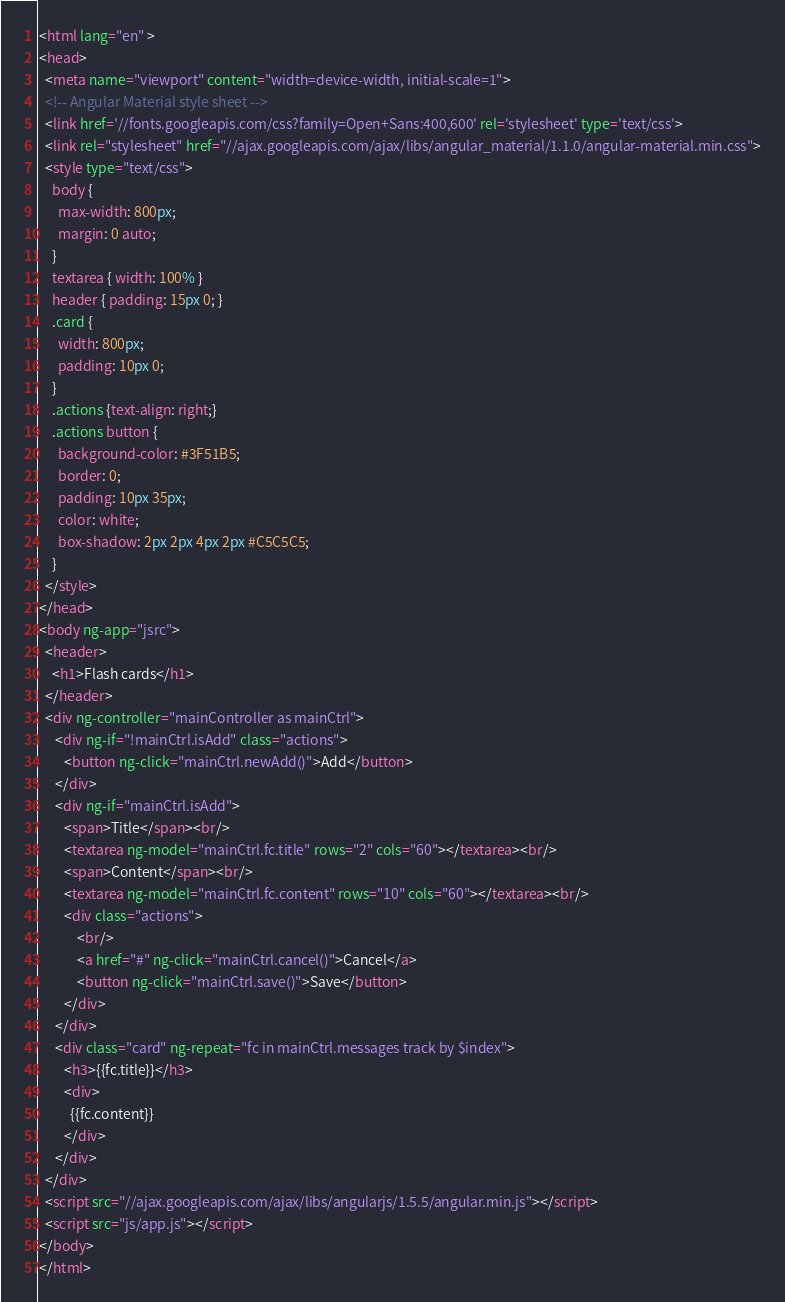<code> <loc_0><loc_0><loc_500><loc_500><_HTML_><html lang="en" >
<head>
  <meta name="viewport" content="width=device-width, initial-scale=1">
  <!-- Angular Material style sheet -->
  <link href='//fonts.googleapis.com/css?family=Open+Sans:400,600' rel='stylesheet' type='text/css'>
  <link rel="stylesheet" href="//ajax.googleapis.com/ajax/libs/angular_material/1.1.0/angular-material.min.css">
  <style type="text/css">
    body {
      max-width: 800px;
      margin: 0 auto;
    }    
    textarea { width: 100% }    
    header { padding: 15px 0; }        
    .card {
      width: 800px;
      padding: 10px 0;
    }
    .actions {text-align: right;}
    .actions button {
      background-color: #3F51B5;
	  border: 0;
	  padding: 10px 35px;
	  color: white;
	  box-shadow: 2px 2px 4px 2px #C5C5C5;
    }
  </style>
</head>
<body ng-app="jsrc">
  <header>
	<h1>Flash cards</h1>
  </header>
  <div ng-controller="mainController as mainCtrl">
  	 <div ng-if="!mainCtrl.isAdd" class="actions">
  	 	<button ng-click="mainCtrl.newAdd()">Add</button>
  	 </div>
  	 <div ng-if="mainCtrl.isAdd">
  	 	<span>Title</span><br/>
  	 	<textarea ng-model="mainCtrl.fc.title" rows="2" cols="60"></textarea><br/>
		<span>Content</span><br/>
  	 	<textarea ng-model="mainCtrl.fc.content" rows="10" cols="60"></textarea><br/>
		<div class="actions">
			<br/>			
			<a href="#" ng-click="mainCtrl.cancel()">Cancel</a>
  	 		<button ng-click="mainCtrl.save()">Save</button>
  	    </div>		  	 	
  	 </div>
     <div class="card" ng-repeat="fc in mainCtrl.messages track by $index">
     	<h3>{{fc.title}}</h3>
     	<div>
     	  {{fc.content}}
     	</div>
     </div>
  </div>  
  <script src="//ajax.googleapis.com/ajax/libs/angularjs/1.5.5/angular.min.js"></script>
  <script src="js/app.js"></script> 
</body>
</html>
</code> 